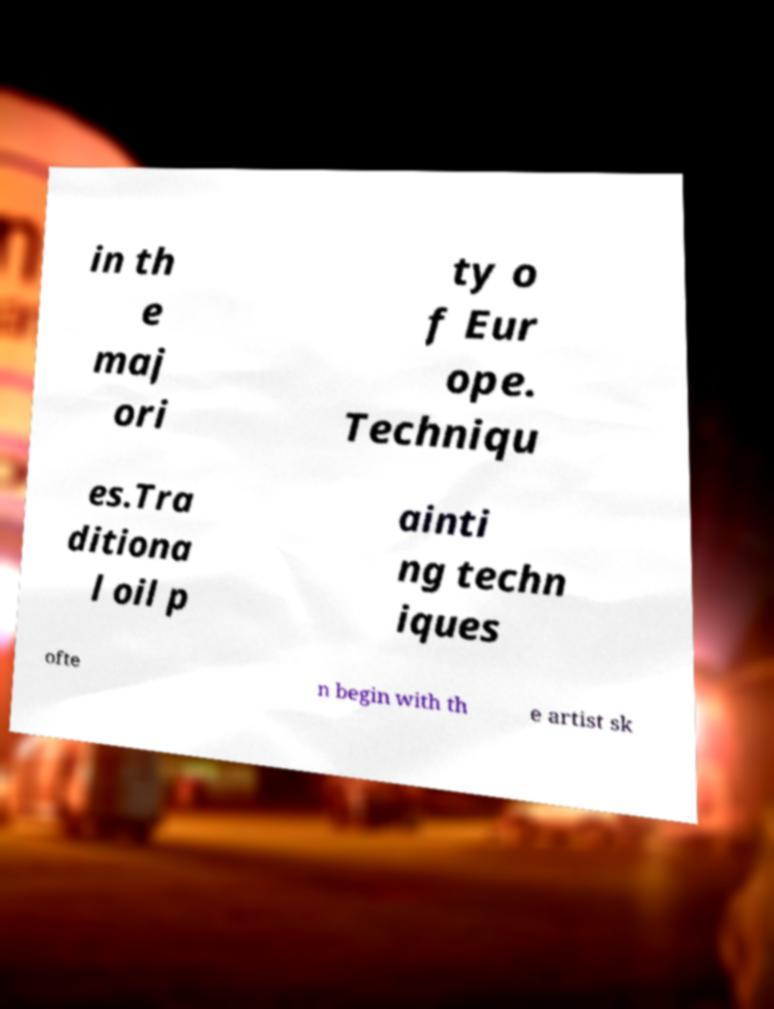Could you assist in decoding the text presented in this image and type it out clearly? in th e maj ori ty o f Eur ope. Techniqu es.Tra ditiona l oil p ainti ng techn iques ofte n begin with th e artist sk 